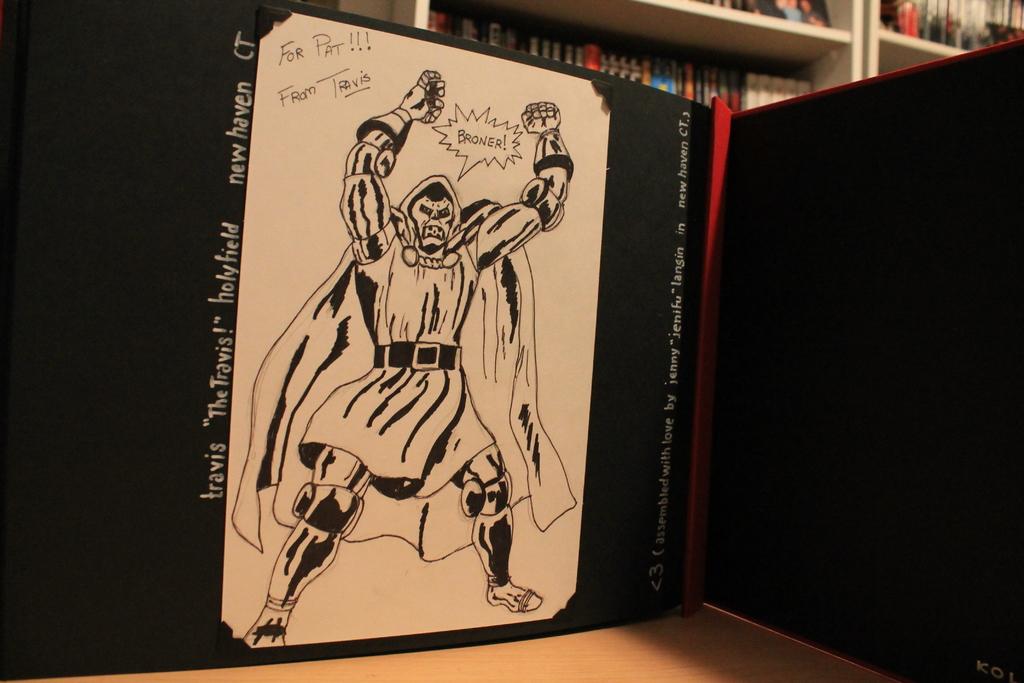Who is the artwork for?
Offer a terse response. Pat. 